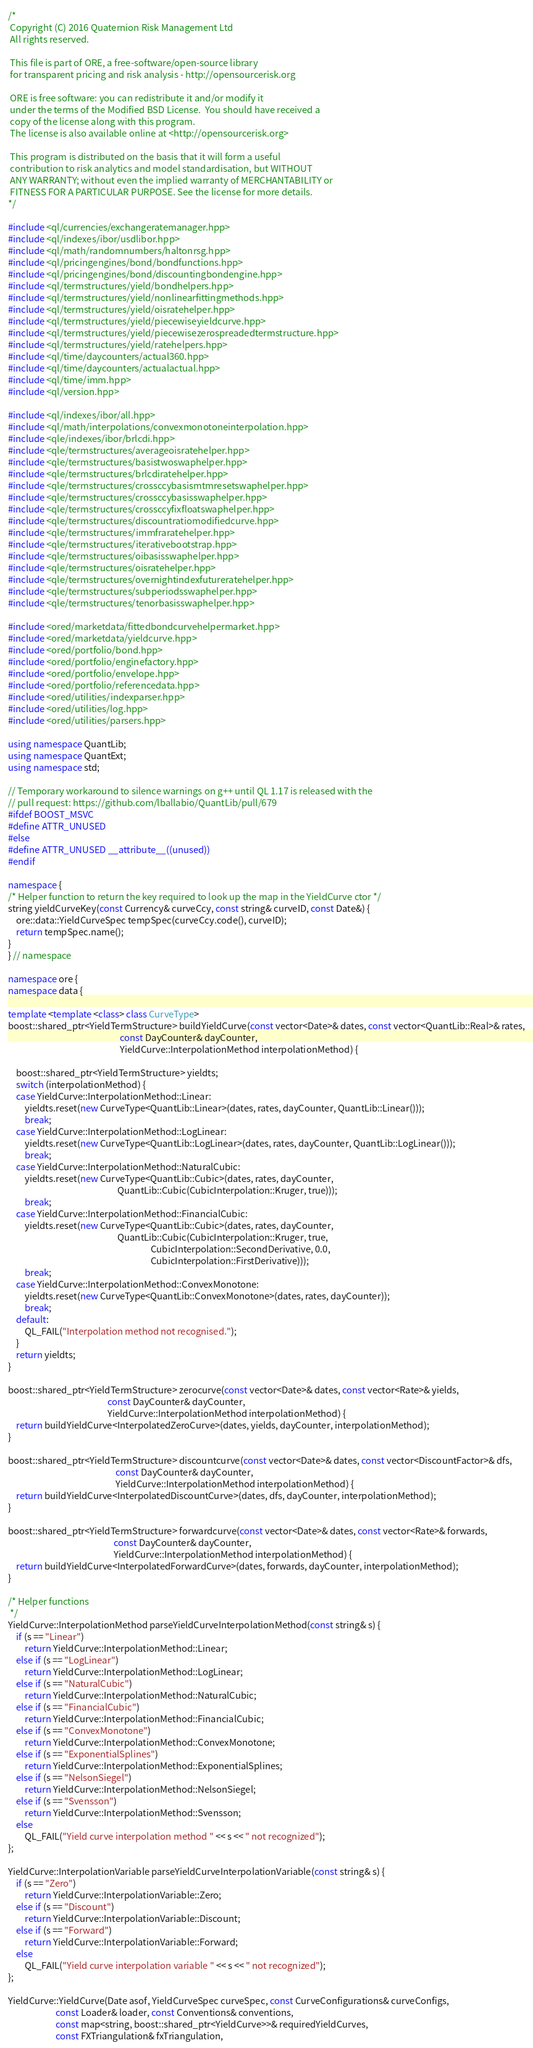<code> <loc_0><loc_0><loc_500><loc_500><_C++_>/*
 Copyright (C) 2016 Quaternion Risk Management Ltd
 All rights reserved.

 This file is part of ORE, a free-software/open-source library
 for transparent pricing and risk analysis - http://opensourcerisk.org

 ORE is free software: you can redistribute it and/or modify it
 under the terms of the Modified BSD License.  You should have received a
 copy of the license along with this program.
 The license is also available online at <http://opensourcerisk.org>

 This program is distributed on the basis that it will form a useful
 contribution to risk analytics and model standardisation, but WITHOUT
 ANY WARRANTY; without even the implied warranty of MERCHANTABILITY or
 FITNESS FOR A PARTICULAR PURPOSE. See the license for more details.
*/

#include <ql/currencies/exchangeratemanager.hpp>
#include <ql/indexes/ibor/usdlibor.hpp>
#include <ql/math/randomnumbers/haltonrsg.hpp>
#include <ql/pricingengines/bond/bondfunctions.hpp>
#include <ql/pricingengines/bond/discountingbondengine.hpp>
#include <ql/termstructures/yield/bondhelpers.hpp>
#include <ql/termstructures/yield/nonlinearfittingmethods.hpp>
#include <ql/termstructures/yield/oisratehelper.hpp>
#include <ql/termstructures/yield/piecewiseyieldcurve.hpp>
#include <ql/termstructures/yield/piecewisezerospreadedtermstructure.hpp>
#include <ql/termstructures/yield/ratehelpers.hpp>
#include <ql/time/daycounters/actual360.hpp>
#include <ql/time/daycounters/actualactual.hpp>
#include <ql/time/imm.hpp>
#include <ql/version.hpp>

#include <ql/indexes/ibor/all.hpp>
#include <ql/math/interpolations/convexmonotoneinterpolation.hpp>
#include <qle/indexes/ibor/brlcdi.hpp>
#include <qle/termstructures/averageoisratehelper.hpp>
#include <qle/termstructures/basistwoswaphelper.hpp>
#include <qle/termstructures/brlcdiratehelper.hpp>
#include <qle/termstructures/crossccybasismtmresetswaphelper.hpp>
#include <qle/termstructures/crossccybasisswaphelper.hpp>
#include <qle/termstructures/crossccyfixfloatswaphelper.hpp>
#include <qle/termstructures/discountratiomodifiedcurve.hpp>
#include <qle/termstructures/immfraratehelper.hpp>
#include <qle/termstructures/iterativebootstrap.hpp>
#include <qle/termstructures/oibasisswaphelper.hpp>
#include <qle/termstructures/oisratehelper.hpp>
#include <qle/termstructures/overnightindexfutureratehelper.hpp>
#include <qle/termstructures/subperiodsswaphelper.hpp>
#include <qle/termstructures/tenorbasisswaphelper.hpp>

#include <ored/marketdata/fittedbondcurvehelpermarket.hpp>
#include <ored/marketdata/yieldcurve.hpp>
#include <ored/portfolio/bond.hpp>
#include <ored/portfolio/enginefactory.hpp>
#include <ored/portfolio/envelope.hpp>
#include <ored/portfolio/referencedata.hpp>
#include <ored/utilities/indexparser.hpp>
#include <ored/utilities/log.hpp>
#include <ored/utilities/parsers.hpp>

using namespace QuantLib;
using namespace QuantExt;
using namespace std;

// Temporary workaround to silence warnings on g++ until QL 1.17 is released with the
// pull request: https://github.com/lballabio/QuantLib/pull/679
#ifdef BOOST_MSVC
#define ATTR_UNUSED
#else
#define ATTR_UNUSED __attribute__((unused))
#endif

namespace {
/* Helper function to return the key required to look up the map in the YieldCurve ctor */
string yieldCurveKey(const Currency& curveCcy, const string& curveID, const Date&) {
    ore::data::YieldCurveSpec tempSpec(curveCcy.code(), curveID);
    return tempSpec.name();
}
} // namespace

namespace ore {
namespace data {

template <template <class> class CurveType>
boost::shared_ptr<YieldTermStructure> buildYieldCurve(const vector<Date>& dates, const vector<QuantLib::Real>& rates,
                                                      const DayCounter& dayCounter,
                                                      YieldCurve::InterpolationMethod interpolationMethod) {

    boost::shared_ptr<YieldTermStructure> yieldts;
    switch (interpolationMethod) {
    case YieldCurve::InterpolationMethod::Linear:
        yieldts.reset(new CurveType<QuantLib::Linear>(dates, rates, dayCounter, QuantLib::Linear()));
        break;
    case YieldCurve::InterpolationMethod::LogLinear:
        yieldts.reset(new CurveType<QuantLib::LogLinear>(dates, rates, dayCounter, QuantLib::LogLinear()));
        break;
    case YieldCurve::InterpolationMethod::NaturalCubic:
        yieldts.reset(new CurveType<QuantLib::Cubic>(dates, rates, dayCounter,
                                                     QuantLib::Cubic(CubicInterpolation::Kruger, true)));
        break;
    case YieldCurve::InterpolationMethod::FinancialCubic:
        yieldts.reset(new CurveType<QuantLib::Cubic>(dates, rates, dayCounter,
                                                     QuantLib::Cubic(CubicInterpolation::Kruger, true,
                                                                     CubicInterpolation::SecondDerivative, 0.0,
                                                                     CubicInterpolation::FirstDerivative)));
        break;
    case YieldCurve::InterpolationMethod::ConvexMonotone:
        yieldts.reset(new CurveType<QuantLib::ConvexMonotone>(dates, rates, dayCounter));
        break;
    default:
        QL_FAIL("Interpolation method not recognised.");
    }
    return yieldts;
}

boost::shared_ptr<YieldTermStructure> zerocurve(const vector<Date>& dates, const vector<Rate>& yields,
                                                const DayCounter& dayCounter,
                                                YieldCurve::InterpolationMethod interpolationMethod) {
    return buildYieldCurve<InterpolatedZeroCurve>(dates, yields, dayCounter, interpolationMethod);
}

boost::shared_ptr<YieldTermStructure> discountcurve(const vector<Date>& dates, const vector<DiscountFactor>& dfs,
                                                    const DayCounter& dayCounter,
                                                    YieldCurve::InterpolationMethod interpolationMethod) {
    return buildYieldCurve<InterpolatedDiscountCurve>(dates, dfs, dayCounter, interpolationMethod);
}

boost::shared_ptr<YieldTermStructure> forwardcurve(const vector<Date>& dates, const vector<Rate>& forwards,
                                                   const DayCounter& dayCounter,
                                                   YieldCurve::InterpolationMethod interpolationMethod) {
    return buildYieldCurve<InterpolatedForwardCurve>(dates, forwards, dayCounter, interpolationMethod);
}

/* Helper functions
 */
YieldCurve::InterpolationMethod parseYieldCurveInterpolationMethod(const string& s) {
    if (s == "Linear")
        return YieldCurve::InterpolationMethod::Linear;
    else if (s == "LogLinear")
        return YieldCurve::InterpolationMethod::LogLinear;
    else if (s == "NaturalCubic")
        return YieldCurve::InterpolationMethod::NaturalCubic;
    else if (s == "FinancialCubic")
        return YieldCurve::InterpolationMethod::FinancialCubic;
    else if (s == "ConvexMonotone")
        return YieldCurve::InterpolationMethod::ConvexMonotone;
    else if (s == "ExponentialSplines")
        return YieldCurve::InterpolationMethod::ExponentialSplines;
    else if (s == "NelsonSiegel")
        return YieldCurve::InterpolationMethod::NelsonSiegel;
    else if (s == "Svensson")
        return YieldCurve::InterpolationMethod::Svensson;
    else
        QL_FAIL("Yield curve interpolation method " << s << " not recognized");
};

YieldCurve::InterpolationVariable parseYieldCurveInterpolationVariable(const string& s) {
    if (s == "Zero")
        return YieldCurve::InterpolationVariable::Zero;
    else if (s == "Discount")
        return YieldCurve::InterpolationVariable::Discount;
    else if (s == "Forward")
        return YieldCurve::InterpolationVariable::Forward;
    else
        QL_FAIL("Yield curve interpolation variable " << s << " not recognized");
};

YieldCurve::YieldCurve(Date asof, YieldCurveSpec curveSpec, const CurveConfigurations& curveConfigs,
                       const Loader& loader, const Conventions& conventions,
                       const map<string, boost::shared_ptr<YieldCurve>>& requiredYieldCurves,
                       const FXTriangulation& fxTriangulation,</code> 